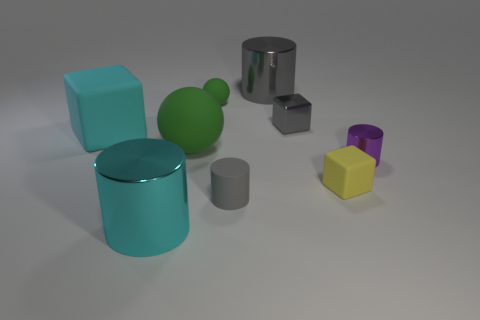Subtract all balls. How many objects are left? 7 Add 4 blue cylinders. How many blue cylinders exist? 4 Subtract 0 red spheres. How many objects are left? 9 Subtract all big green metal spheres. Subtract all tiny purple cylinders. How many objects are left? 8 Add 5 big gray things. How many big gray things are left? 6 